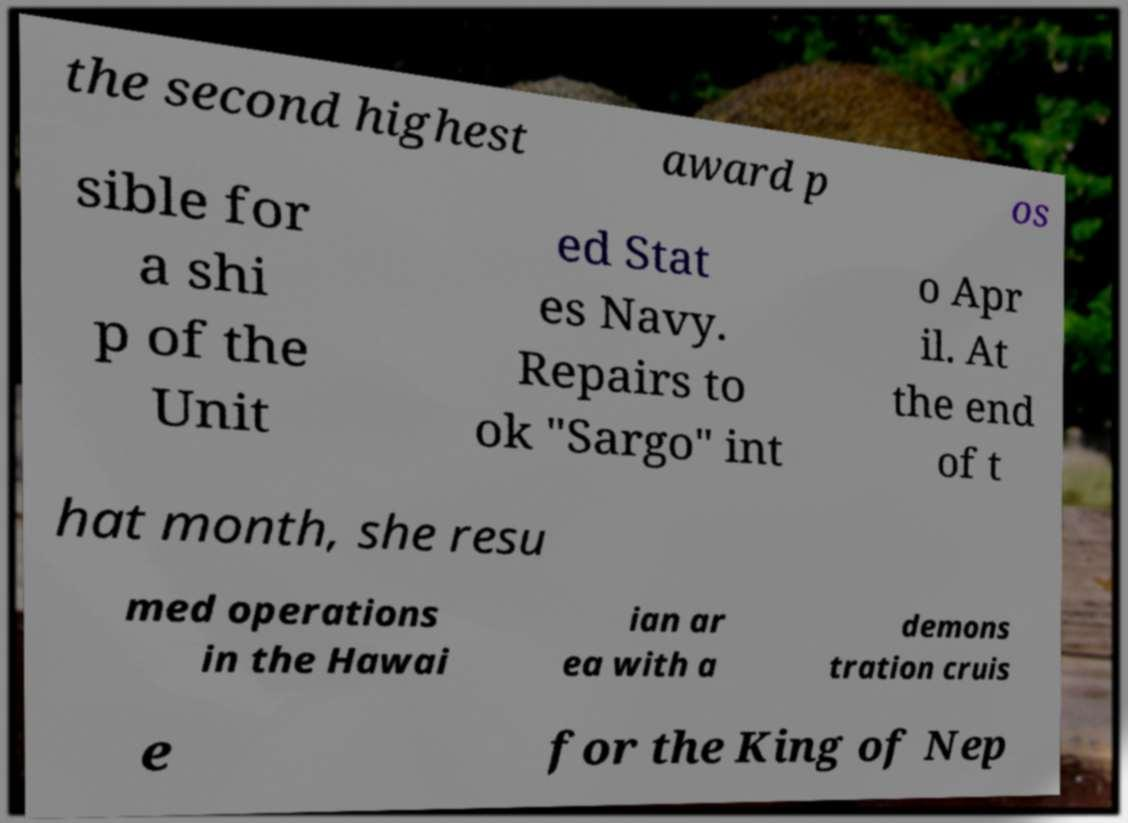I need the written content from this picture converted into text. Can you do that? the second highest award p os sible for a shi p of the Unit ed Stat es Navy. Repairs to ok "Sargo" int o Apr il. At the end of t hat month, she resu med operations in the Hawai ian ar ea with a demons tration cruis e for the King of Nep 